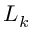<formula> <loc_0><loc_0><loc_500><loc_500>L _ { k }</formula> 